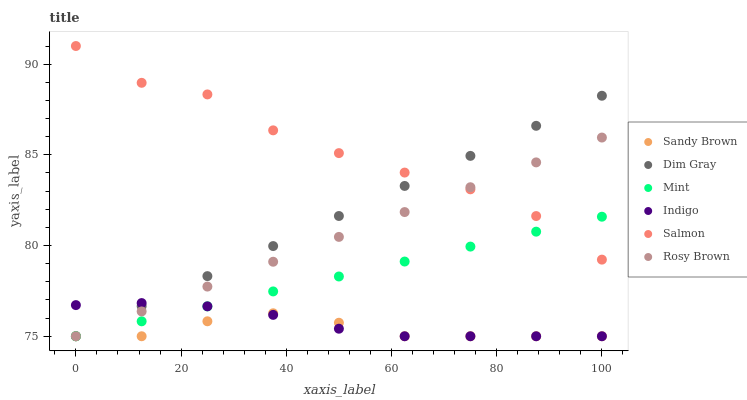Does Sandy Brown have the minimum area under the curve?
Answer yes or no. Yes. Does Salmon have the maximum area under the curve?
Answer yes or no. Yes. Does Indigo have the minimum area under the curve?
Answer yes or no. No. Does Indigo have the maximum area under the curve?
Answer yes or no. No. Is Mint the smoothest?
Answer yes or no. Yes. Is Salmon the roughest?
Answer yes or no. Yes. Is Indigo the smoothest?
Answer yes or no. No. Is Indigo the roughest?
Answer yes or no. No. Does Dim Gray have the lowest value?
Answer yes or no. Yes. Does Salmon have the lowest value?
Answer yes or no. No. Does Salmon have the highest value?
Answer yes or no. Yes. Does Indigo have the highest value?
Answer yes or no. No. Is Sandy Brown less than Salmon?
Answer yes or no. Yes. Is Salmon greater than Sandy Brown?
Answer yes or no. Yes. Does Dim Gray intersect Indigo?
Answer yes or no. Yes. Is Dim Gray less than Indigo?
Answer yes or no. No. Is Dim Gray greater than Indigo?
Answer yes or no. No. Does Sandy Brown intersect Salmon?
Answer yes or no. No. 